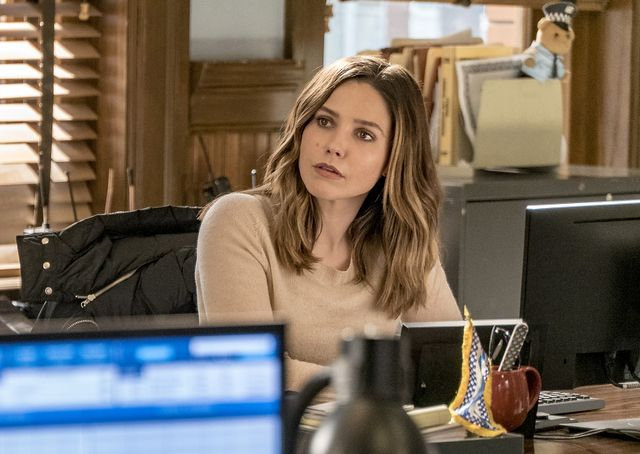What do you see happening in this image? In the image, a woman appears to be deeply focused and possibly analyzing a situation. She is seated in an office environment, featuring what seems to be a work desk cluttered with various items including a computer monitor, stationery, and a coffee mug. Her earnest expression and direct gaze suggest she could be in the middle of a critical decision-making process or problem-solving. The warm lighting and casual attire add a sense of everyday work life to the scene. 